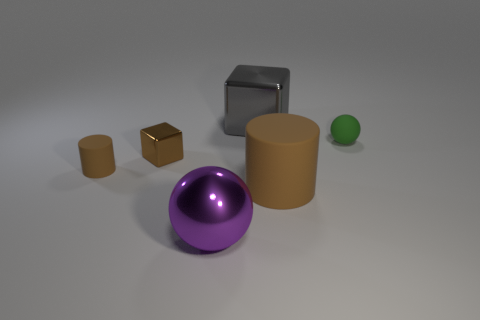Subtract all gray blocks. Subtract all cyan balls. How many blocks are left? 1 Add 3 large rubber cylinders. How many objects exist? 9 Subtract all balls. How many objects are left? 4 Add 1 brown cylinders. How many brown cylinders are left? 3 Add 3 small matte cylinders. How many small matte cylinders exist? 4 Subtract 0 red cylinders. How many objects are left? 6 Subtract all small gray objects. Subtract all tiny things. How many objects are left? 3 